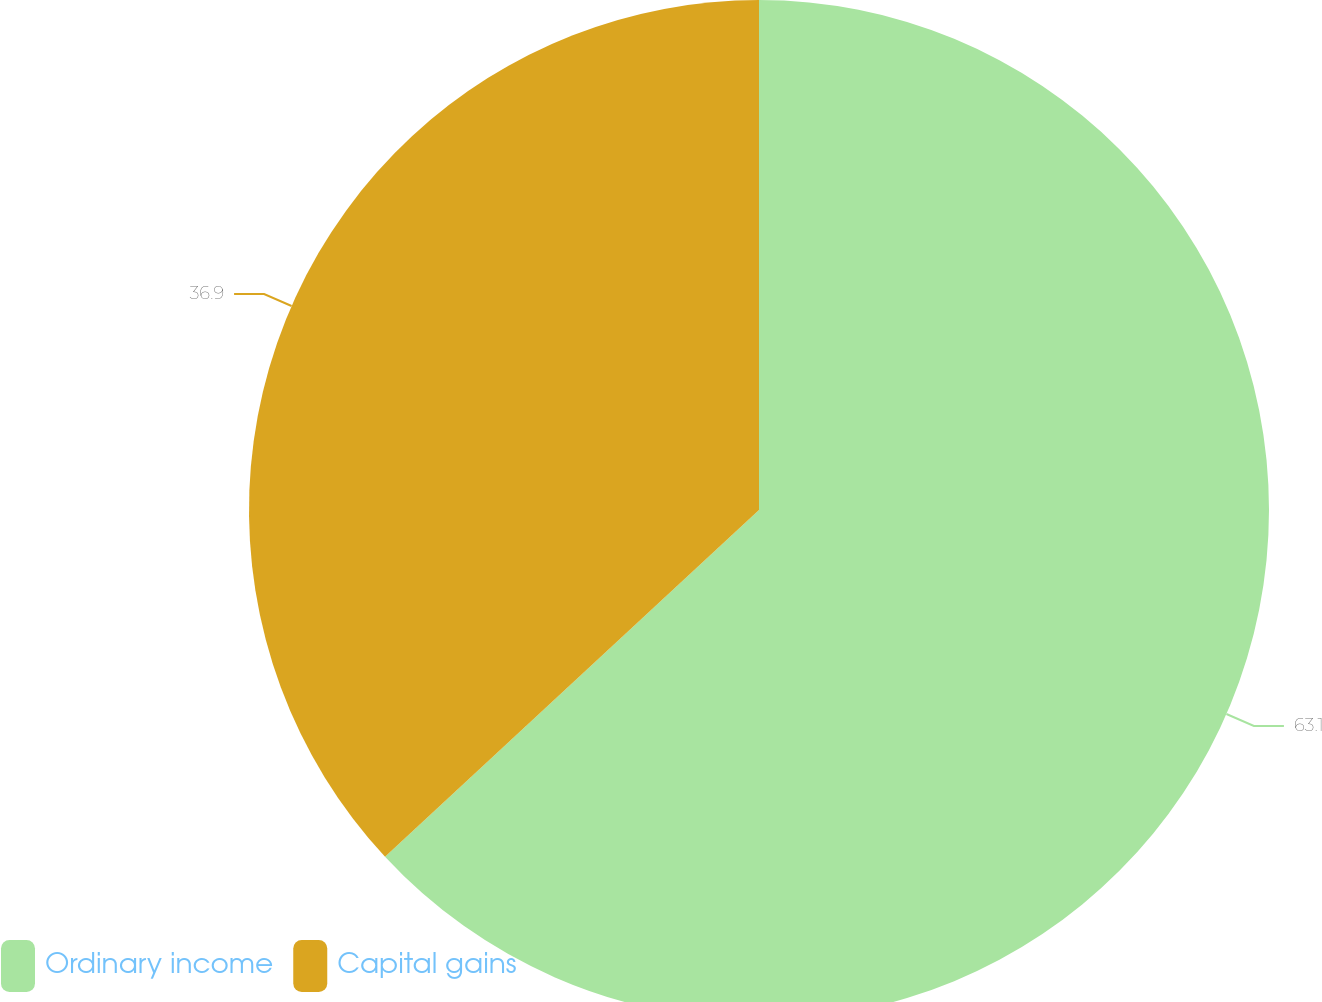Convert chart. <chart><loc_0><loc_0><loc_500><loc_500><pie_chart><fcel>Ordinary income<fcel>Capital gains<nl><fcel>63.1%<fcel>36.9%<nl></chart> 